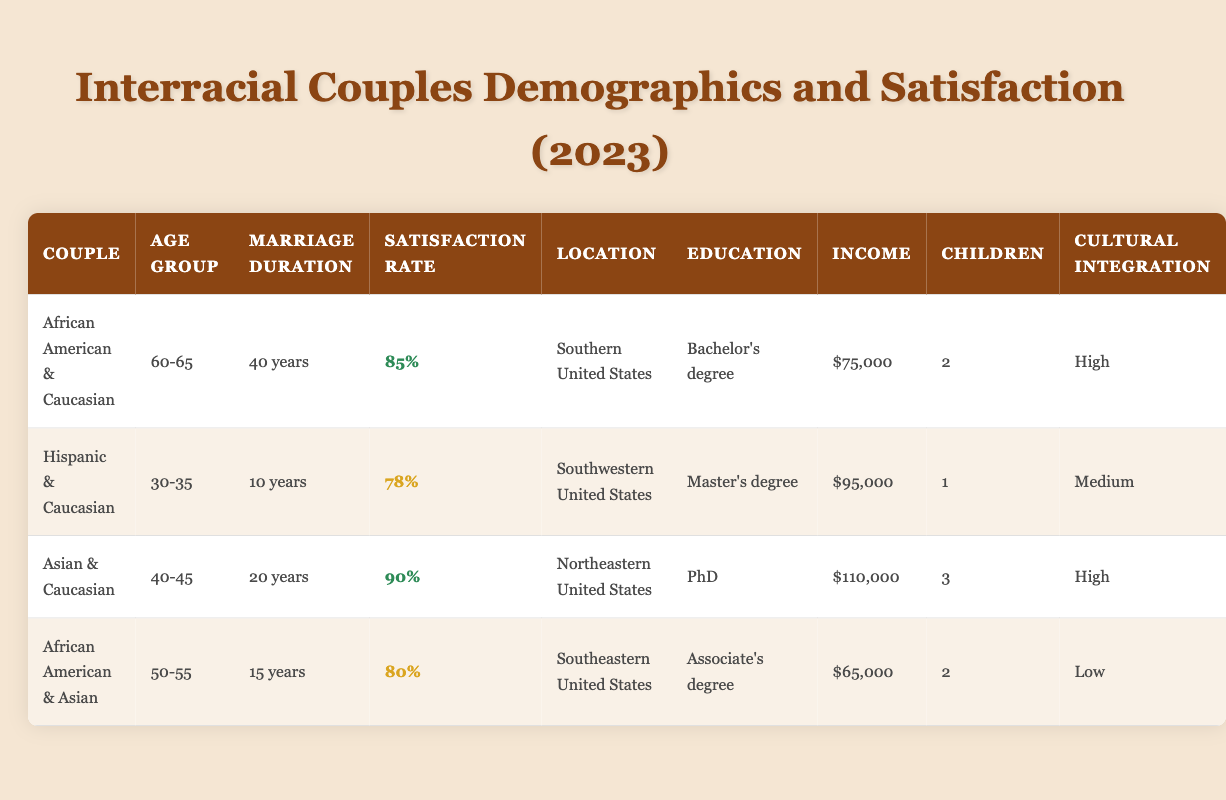What is the satisfaction rate for the African American and Caucasian couple? The table shows that the satisfaction rate for the African American and Caucasian couple is listed as 85%.
Answer: 85% Which couple has the highest satisfaction rate? Looking at the satisfaction rates, the Asian and Caucasian couple has the highest rate at 90%.
Answer: Asian and Caucasian couple How many years have the African American and Asian couple been married? From the table, the African American and Asian couple has been married for 15 years.
Answer: 15 years What is the average household income of all the couples listed? Adding the household incomes: 75000 + 95000 + 110000 + 65000 = 335000. There are 4 couples, so the average income is 335000 / 4 = 83750.
Answer: 83750 Is it true that all couples in the table have children? By checking the data, all couples listed have either 1 or 2 or 3 children, which means they all have children.
Answer: Yes What is the marital duration difference between the couple with the highest satisfaction rate and the couple with the lowest? The Asian and Caucasian couple has a marital duration of 20 years, and the African American and Asian couple has a duration of 15 years. The difference is 20 - 15 = 5 years.
Answer: 5 years Do couples with higher education levels tend to have higher satisfaction rates based on this table? Analyzing the couples, the ones with Bachelor's and Master's degrees have lower satisfaction (85% and 78%), but the ones with PhD and Associate's degrees have higher satisfaction (90% and 80%). This suggests no clear trend in this limited dataset.
Answer: No Which couple has the lowest cultural integration? The African American and Asian couple has the lowest cultural integration, marked as Low in the table.
Answer: African American and Asian couple What education level does the couple with the longest marriage have? The African American and Caucasian couple, who has been married for 40 years, has a Bachelor's degree.
Answer: Bachelor's degree 